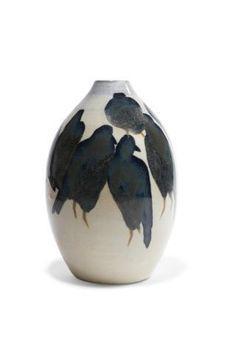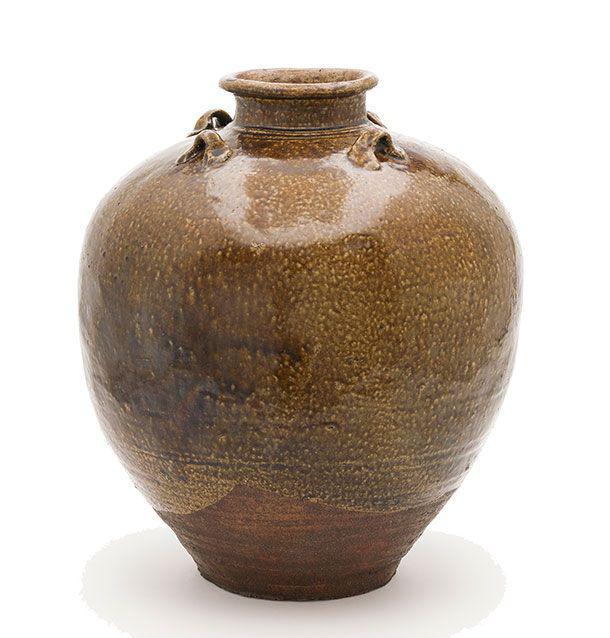The first image is the image on the left, the second image is the image on the right. Analyze the images presented: Is the assertion "The left image contains a set of three vases with similar patterns but different shapes and heights." valid? Answer yes or no. No. The first image is the image on the left, the second image is the image on the right. Assess this claim about the two images: "there are three vases of varying sizes". Correct or not? Answer yes or no. No. 